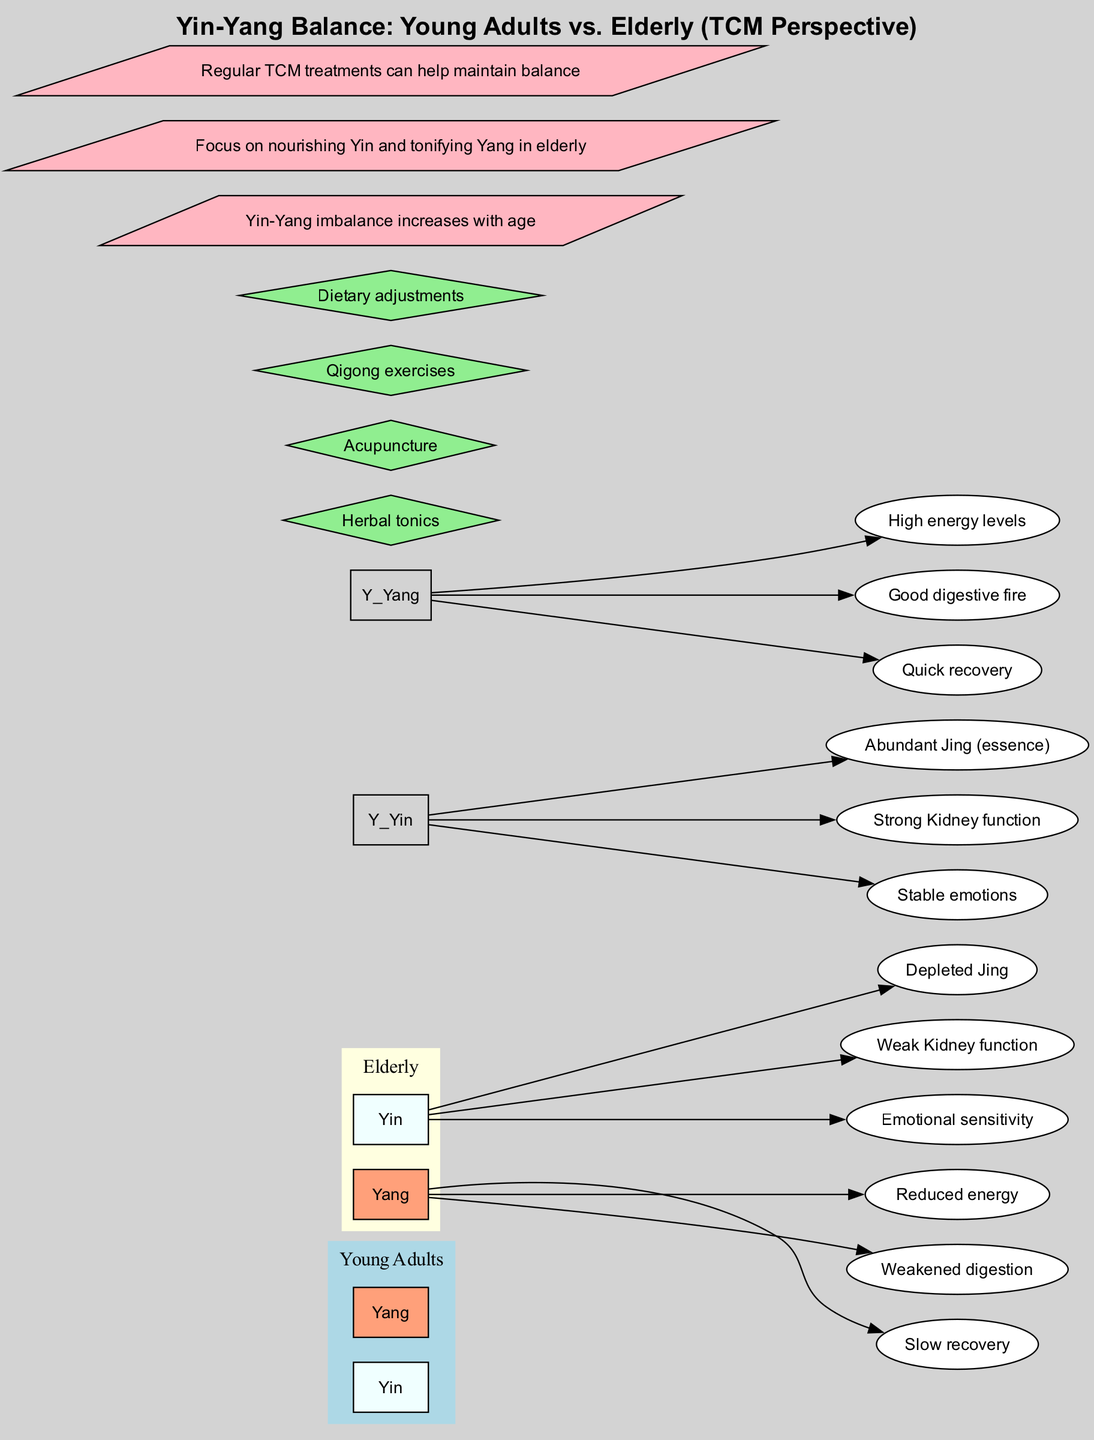What are the characteristics of Yin in young adults? The diagram shows "Young Adults" on the left side with the "Yin" node connecting to three oval nodes below it. These characteristics are "Abundant Jing (essence)", "Strong Kidney function", and "Stable emotions".
Answer: Abundant Jing (essence), Strong Kidney function, Stable emotions What is one key point regarding Yin-Yang imbalance? The diagram lists key points at the bottom, with one point stating "Yin-Yang imbalance increases with age", indicating a general trend highlighted in the diagram regarding aging and Yin-Yang balance.
Answer: Yin-Yang imbalance increases with age How many main categories are there in the diagram? The diagram has two main categories at the top: "Young Adults" and "Elderly", which can be counted directly from the top section of the diagram.
Answer: 2 What are the characteristics of Yang in elderly individuals? In the diagram, under the "Elderly" category and the "Yang" node, the characteristics list includes "Reduced energy", "Weakened digestion", and "Slow recovery", found directly below the Yang node on the right side.
Answer: Reduced energy, Weakened digestion, Slow recovery Which balancing method is listed in the diagram? The diagram contains a section for "balancing methods", where several methods are listed in a diamond shape, including "Herbal tonics". This implies that these methods are meant to help restore Yin-Yang balance.
Answer: Herbal tonics Why is nourishing Yin important for the elderly according to the diagram? One of the key points states "Focus on nourishing Yin and tonifying Yang in elderly", highlighting that as individuals age, it becomes especially important to balance these energies. This reflects the relationship between aging and health specific to TCM principles.
Answer: Focus on nourishing Yin and tonifying Yang in elderly What is the relationship between "Yang" characteristics in young adults and recovery speed? The diagram shows the "Yang" section under the "Young Adults" category with the characteristic "Quick recovery", indicating a direct relationship where young adults have faster recovery compared to elderly individuals. This can be concluded by comparing the characteristics of both age groups.
Answer: Quick recovery How many methods for balancing Yin-Yang are mentioned? Referring to the methods listed in the lower section of the diagram, there are four methods stated: "Herbal tonics", "Acupuncture", "Qigong exercises", and "Dietary adjustments". Counting these, we find the total.
Answer: 4 